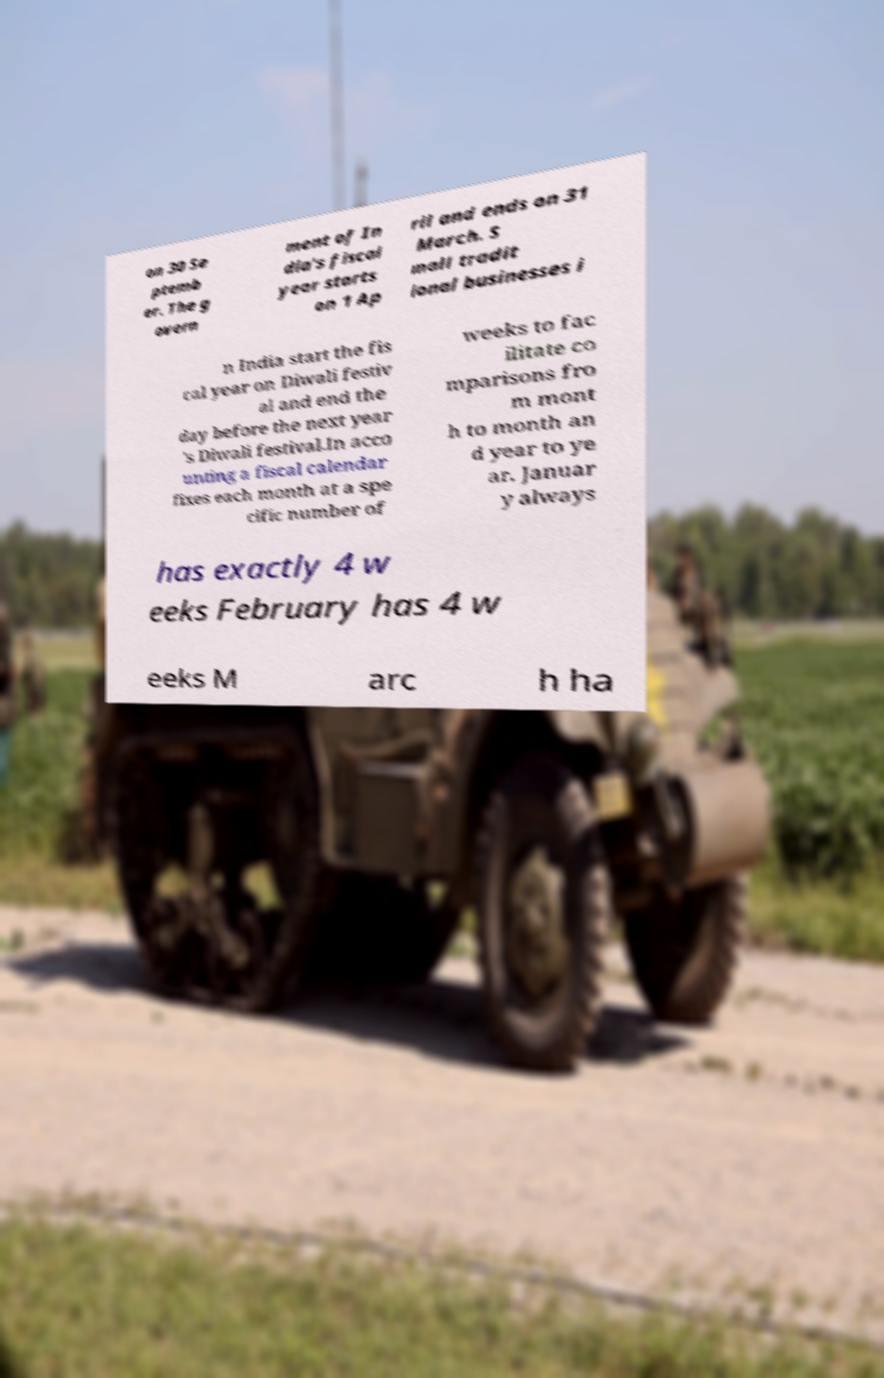There's text embedded in this image that I need extracted. Can you transcribe it verbatim? on 30 Se ptemb er. The g overn ment of In dia's fiscal year starts on 1 Ap ril and ends on 31 March. S mall tradit ional businesses i n India start the fis cal year on Diwali festiv al and end the day before the next year 's Diwali festival.In acco unting a fiscal calendar fixes each month at a spe cific number of weeks to fac ilitate co mparisons fro m mont h to month an d year to ye ar. Januar y always has exactly 4 w eeks February has 4 w eeks M arc h ha 